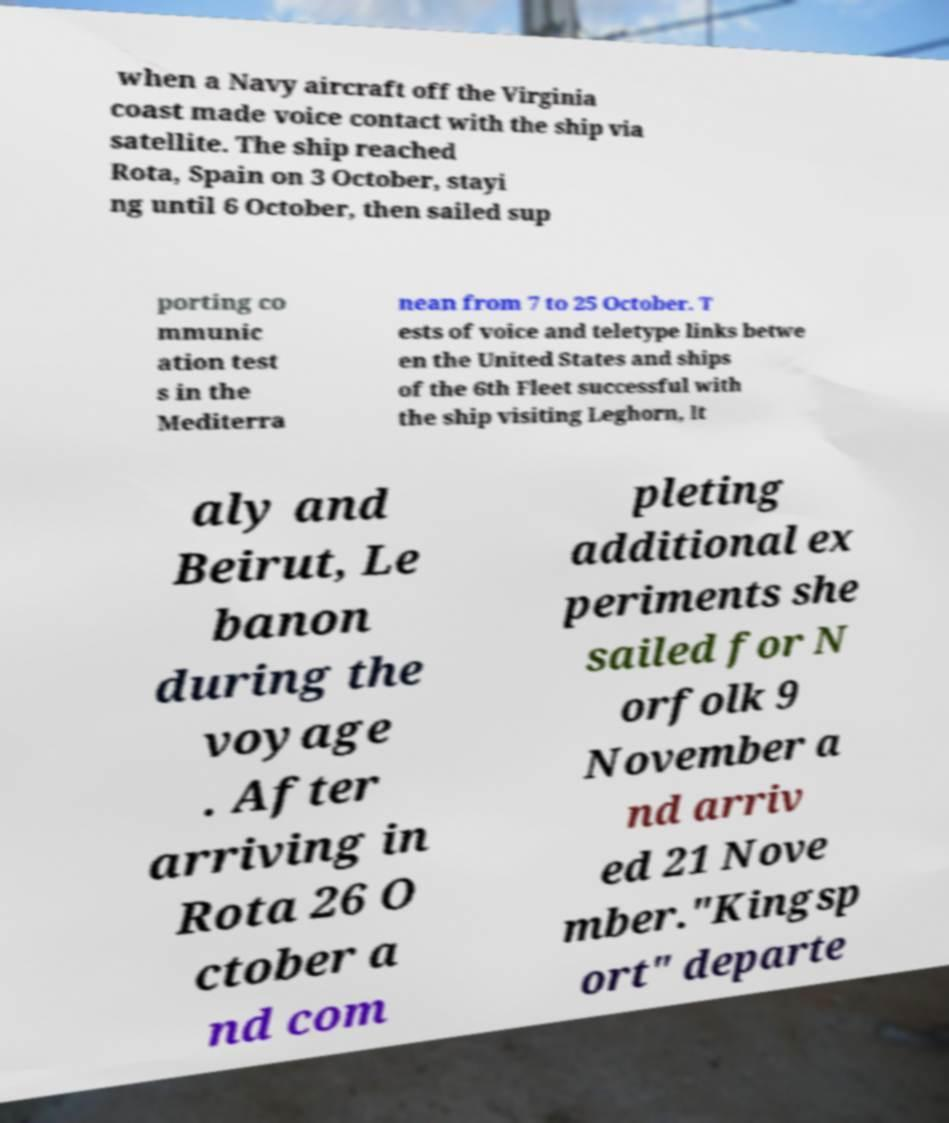Please read and relay the text visible in this image. What does it say? when a Navy aircraft off the Virginia coast made voice contact with the ship via satellite. The ship reached Rota, Spain on 3 October, stayi ng until 6 October, then sailed sup porting co mmunic ation test s in the Mediterra nean from 7 to 25 October. T ests of voice and teletype links betwe en the United States and ships of the 6th Fleet successful with the ship visiting Leghorn, It aly and Beirut, Le banon during the voyage . After arriving in Rota 26 O ctober a nd com pleting additional ex periments she sailed for N orfolk 9 November a nd arriv ed 21 Nove mber."Kingsp ort" departe 